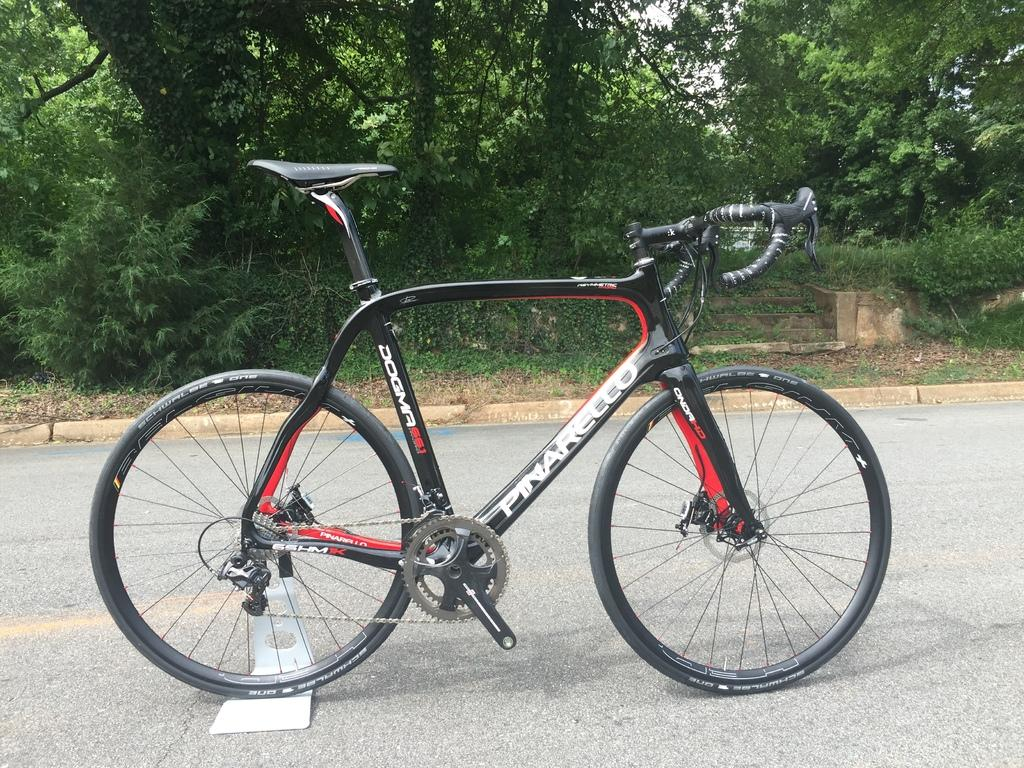What is the main subject in the center of the image? There is a cycle in the center of the image. Where is the cycle located? The cycle is on the road. What can be seen in the background of the image? There are trees and the sky visible in the background of the image. What type of books can be found in the library depicted in the image? There is no library present in the image; it features a cycle on the road with trees and the sky in the background. 